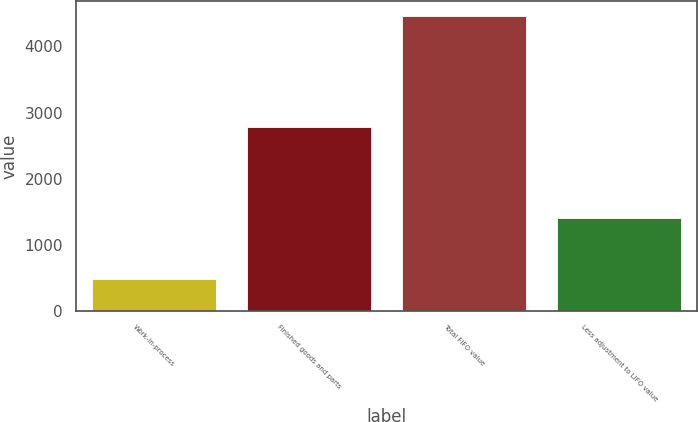<chart> <loc_0><loc_0><loc_500><loc_500><bar_chart><fcel>Work-in-process<fcel>Finished goods and parts<fcel>Total FIFO value<fcel>Less adjustment to LIFO value<nl><fcel>483<fcel>2777<fcel>4461<fcel>1398<nl></chart> 